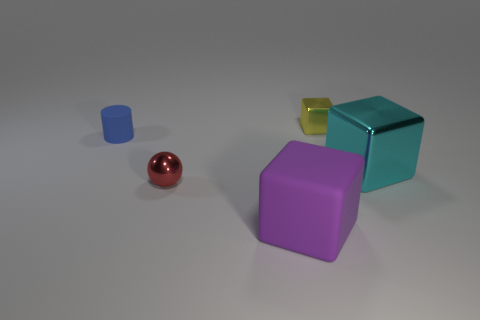There is a large object that is made of the same material as the yellow cube; what is its shape?
Your response must be concise. Cube. Does the tiny metallic object that is left of the matte cube have the same color as the rubber object that is behind the rubber cube?
Offer a terse response. No. Are there an equal number of small red metal balls right of the matte cube and small yellow cubes?
Your response must be concise. No. What number of tiny blue cylinders are right of the small metallic cube?
Ensure brevity in your answer.  0. The red metallic sphere is what size?
Your answer should be compact. Small. There is a big object that is the same material as the tiny blue cylinder; what is its color?
Provide a short and direct response. Purple. How many cyan metal cubes are the same size as the blue cylinder?
Ensure brevity in your answer.  0. Do the large cube in front of the tiny metallic sphere and the tiny yellow cube have the same material?
Your answer should be compact. No. Are there fewer small rubber things in front of the purple block than tiny red blocks?
Ensure brevity in your answer.  No. There is a small shiny object in front of the yellow shiny cube; what shape is it?
Keep it short and to the point. Sphere. 